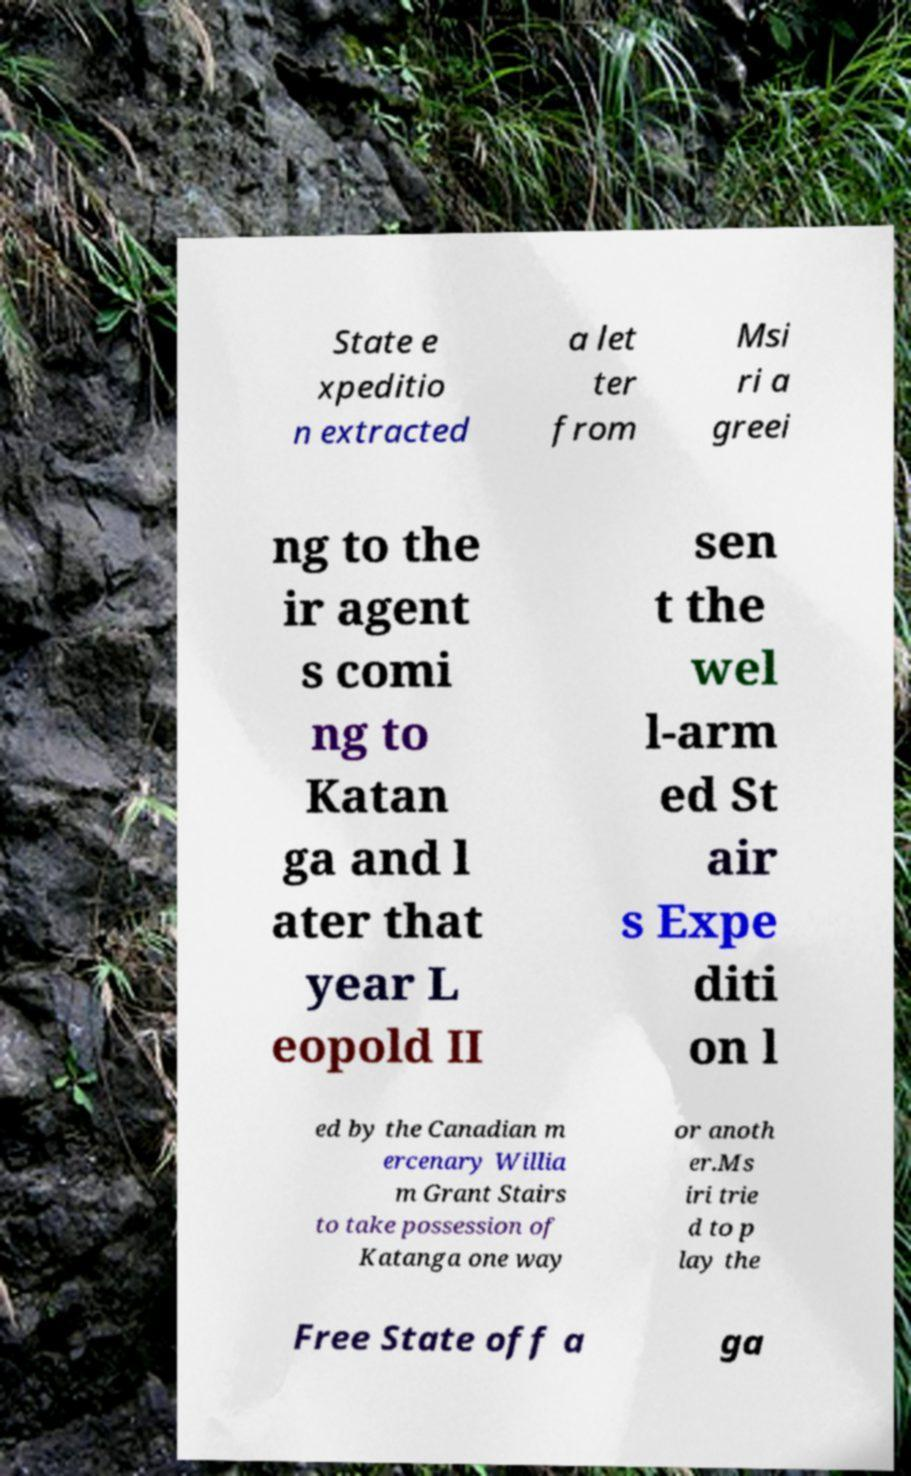Please identify and transcribe the text found in this image. State e xpeditio n extracted a let ter from Msi ri a greei ng to the ir agent s comi ng to Katan ga and l ater that year L eopold II sen t the wel l-arm ed St air s Expe diti on l ed by the Canadian m ercenary Willia m Grant Stairs to take possession of Katanga one way or anoth er.Ms iri trie d to p lay the Free State off a ga 